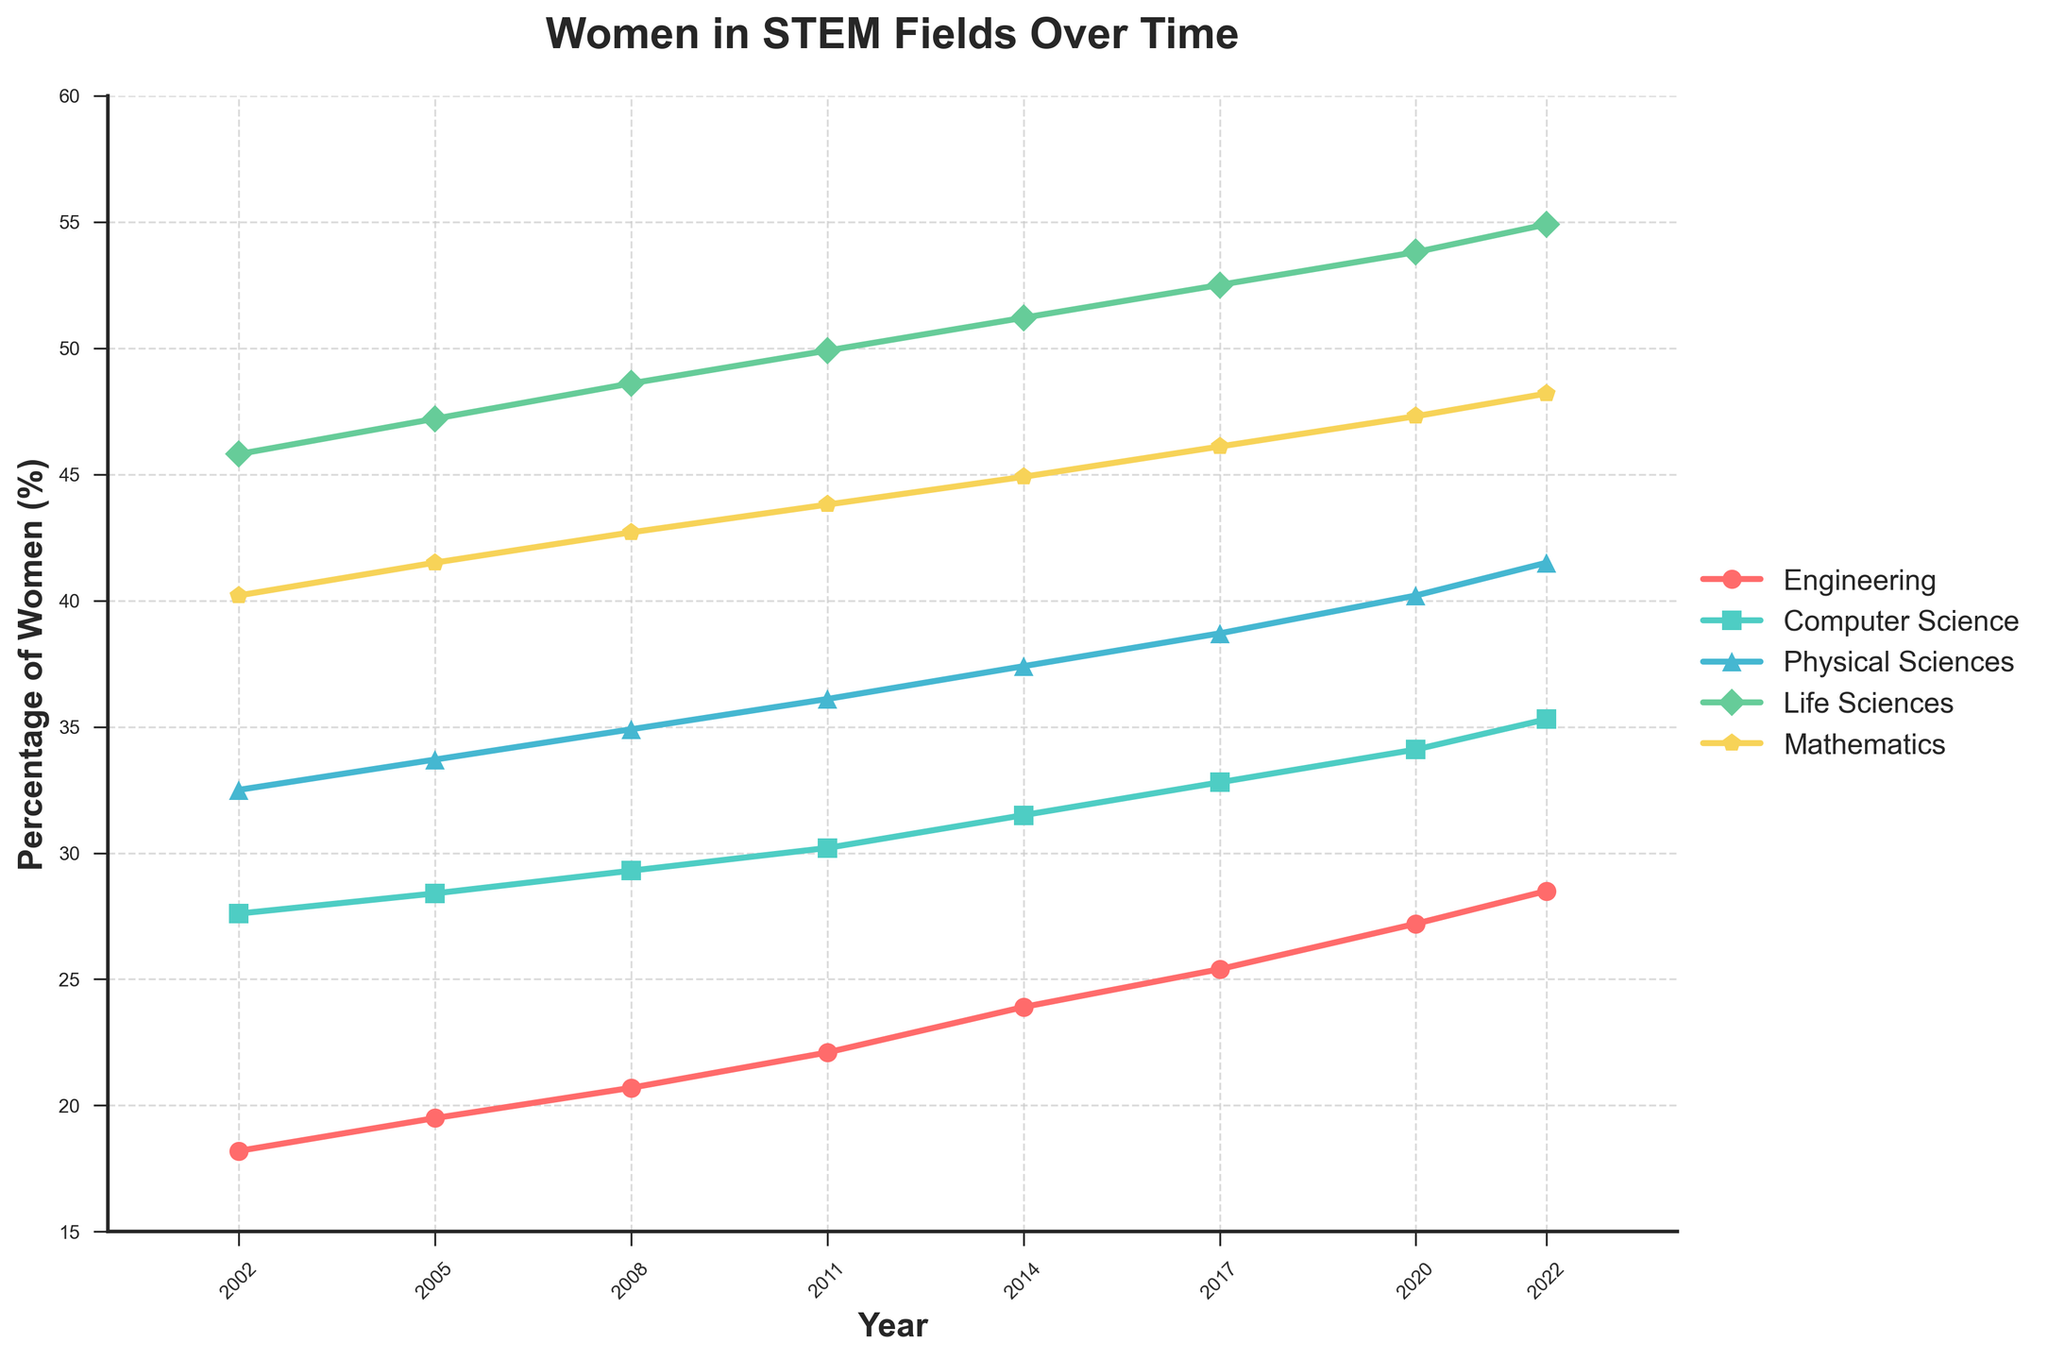what is the increase in the Percentage of Women in Engineering from 2002 to 2022? In 2002, the percentage of women in Engineering was 18.2%. In 2022, it was 28.5%. The increase is calculated by subtracting the 2002 value from the 2022 value: 28.5% - 18.2% = 10.3%.
Answer: 10.3% which field had the highest percentage of women in 2022? By observing the data for 2022, Life Sciences had the highest percentage of women at 54.9%.
Answer: Life Sciences between 2011 and 2017, which field saw the greatest increase in the percentage of women? Compute the increase for each field between 2011 and 2017: 
- Engineering: 25.4% - 22.1% = 3.3%
- Computer Science: 32.8% - 30.2% = 2.6%
- Physical Sciences: 38.7% - 36.1% = 2.6%
- Life Sciences: 52.5% - 49.9% = 2.6%
- Mathematics: 46.1% - 43.8% = 2.3%
The greatest increase is in Engineering at 3.3%.
Answer: Engineering which two fields had the smallest difference in the percentage of women in 2022? First, calculate the differences between the percentages:
- Engineering and Computer Science: 35.3% - 28.5% = 6.8%
- Engineering and Physical Sciences: 41.5% - 28.5% = 13.0%
- Engineering and Life Sciences: 54.9% - 28.5% = 26.4%
- Engineering and Mathematics: 48.2% - 28.5% = 19.7%
- Computer Science and Physical Sciences: 41.5% - 35.3% = 6.2%
- Computer Science and Life Sciences: 54.9% - 35.3% = 19.6%
- Computer Science and Mathematics: 48.2% - 35.3% = 12.9%
- Physical Sciences and Life Sciences: 54.9% - 41.5% = 13.4%
- Physical Sciences and Mathematics: 48.2% - 41.5% = 6.7%
- Life Sciences and Mathematics: 54.9% - 48.2% = 6.7%
The smallest difference is between Computer Science and Physical Sciences (6.2%).
Answer: Computer Science and Physical Sciences from 2002 to 2022, which field shows the most consistent increase in the percentage of women? By visually analyzing the slopes of the lines in the plot, it appears that Life Sciences shows a consistent increase. The yearly increases are steady and there are no major fluctuations.
Answer: Life Sciences how much did the percentage of women in Mathematics change from 2005 to 2022? In 2005, the percentage of women in Mathematics was 41.5%. In 2022, it was 48.2%. The change is calculated as: 48.2% - 41.5% = 6.7%.
Answer: 6.7% in which year did Computer Science surpass 30%? By observing the trend for Computer Science, it surpasses 30% between 2008 and 2011. The exact year from the data provided is 2011.
Answer: 2011 what is the trend for women in Physical Sciences over the 20 years? From 2002 to 2022, the percentage of women in Physical Sciences shows a steady increase. It starts at 32.5% in 2002 and reaches 41.5% in 2022.
Answer: Steady increase which field had the second-highest percentage of women in 2020? By reviewing the data for 2020, Life Sciences had the highest percentage at 53.8%. The next highest was Mathematics at 47.3%.
Answer: Mathematics 